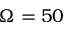Convert formula to latex. <formula><loc_0><loc_0><loc_500><loc_500>\Omega = 5 0</formula> 